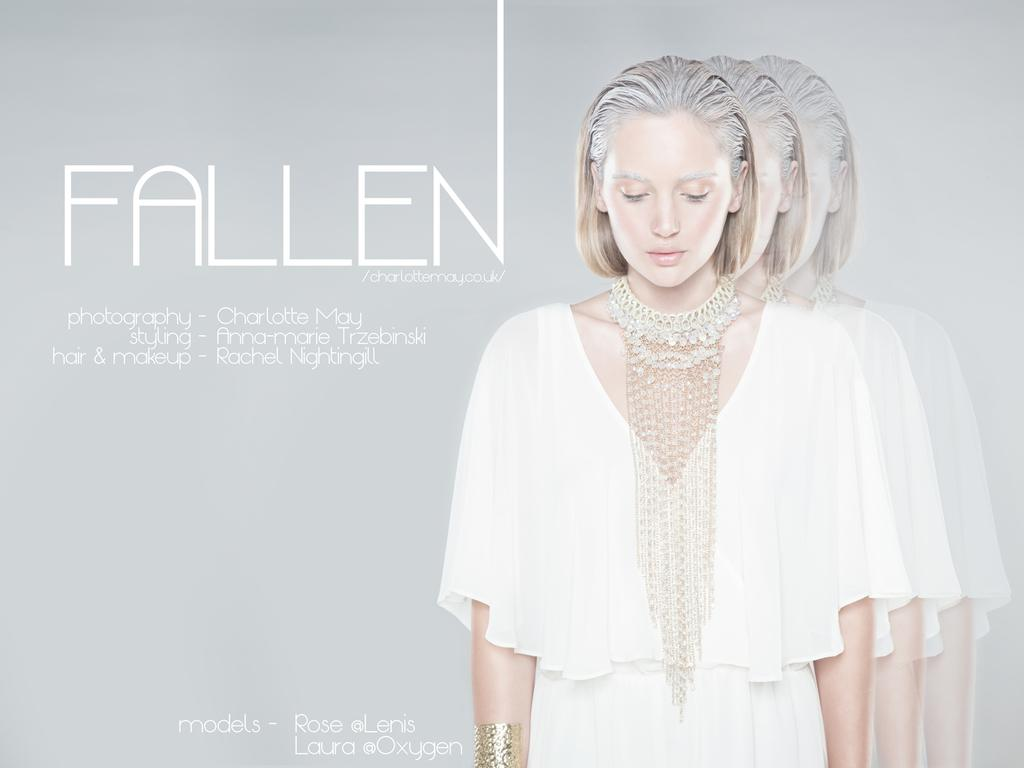Who is the main subject in the image? There is a woman in the image. What is the woman wearing? The woman is wearing a white dress and a necklace. Can you describe the reflection in the image? Yes, there is a reflection of the woman in the image. What else can be seen in the image besides the woman? There is text visible in the image. What type of wristwatch is the woman wearing in the image? The woman is not wearing a wristwatch in the image. What part of the woman's body is visible in the reflection? The reflection in the image shows the woman's entire body, not just a specific part. 